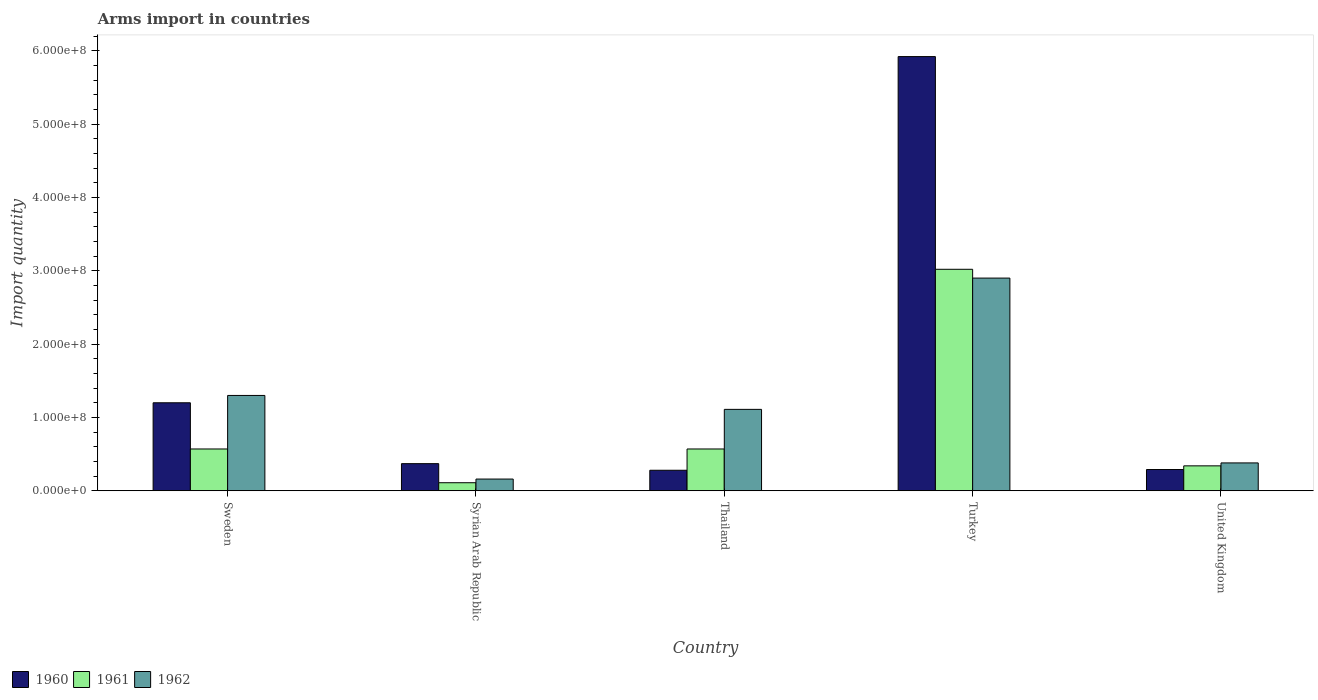How many different coloured bars are there?
Provide a succinct answer. 3. How many groups of bars are there?
Your answer should be compact. 5. Are the number of bars per tick equal to the number of legend labels?
Give a very brief answer. Yes. How many bars are there on the 4th tick from the left?
Provide a succinct answer. 3. How many bars are there on the 1st tick from the right?
Your answer should be compact. 3. What is the label of the 1st group of bars from the left?
Provide a succinct answer. Sweden. In how many cases, is the number of bars for a given country not equal to the number of legend labels?
Your answer should be compact. 0. What is the total arms import in 1960 in Sweden?
Your response must be concise. 1.20e+08. Across all countries, what is the maximum total arms import in 1961?
Your answer should be very brief. 3.02e+08. Across all countries, what is the minimum total arms import in 1962?
Make the answer very short. 1.60e+07. In which country was the total arms import in 1961 minimum?
Your response must be concise. Syrian Arab Republic. What is the total total arms import in 1960 in the graph?
Keep it short and to the point. 8.06e+08. What is the difference between the total arms import in 1962 in Thailand and that in United Kingdom?
Make the answer very short. 7.30e+07. What is the difference between the total arms import in 1960 in Sweden and the total arms import in 1962 in Turkey?
Offer a very short reply. -1.70e+08. What is the average total arms import in 1960 per country?
Offer a very short reply. 1.61e+08. What is the difference between the total arms import of/in 1960 and total arms import of/in 1961 in Syrian Arab Republic?
Your answer should be very brief. 2.60e+07. What is the ratio of the total arms import in 1961 in Sweden to that in Turkey?
Your answer should be compact. 0.19. Is the total arms import in 1961 in Syrian Arab Republic less than that in Turkey?
Make the answer very short. Yes. What is the difference between the highest and the second highest total arms import in 1961?
Offer a terse response. 2.45e+08. What is the difference between the highest and the lowest total arms import in 1962?
Make the answer very short. 2.74e+08. In how many countries, is the total arms import in 1960 greater than the average total arms import in 1960 taken over all countries?
Your answer should be very brief. 1. Is it the case that in every country, the sum of the total arms import in 1962 and total arms import in 1961 is greater than the total arms import in 1960?
Your response must be concise. No. How many bars are there?
Provide a short and direct response. 15. What is the difference between two consecutive major ticks on the Y-axis?
Provide a succinct answer. 1.00e+08. Are the values on the major ticks of Y-axis written in scientific E-notation?
Keep it short and to the point. Yes. How many legend labels are there?
Your answer should be very brief. 3. What is the title of the graph?
Give a very brief answer. Arms import in countries. What is the label or title of the Y-axis?
Give a very brief answer. Import quantity. What is the Import quantity of 1960 in Sweden?
Your answer should be compact. 1.20e+08. What is the Import quantity in 1961 in Sweden?
Provide a succinct answer. 5.70e+07. What is the Import quantity in 1962 in Sweden?
Ensure brevity in your answer.  1.30e+08. What is the Import quantity of 1960 in Syrian Arab Republic?
Your answer should be very brief. 3.70e+07. What is the Import quantity of 1961 in Syrian Arab Republic?
Your answer should be compact. 1.10e+07. What is the Import quantity in 1962 in Syrian Arab Republic?
Offer a very short reply. 1.60e+07. What is the Import quantity in 1960 in Thailand?
Give a very brief answer. 2.80e+07. What is the Import quantity in 1961 in Thailand?
Give a very brief answer. 5.70e+07. What is the Import quantity of 1962 in Thailand?
Your answer should be compact. 1.11e+08. What is the Import quantity in 1960 in Turkey?
Your answer should be very brief. 5.92e+08. What is the Import quantity in 1961 in Turkey?
Offer a terse response. 3.02e+08. What is the Import quantity in 1962 in Turkey?
Your answer should be compact. 2.90e+08. What is the Import quantity of 1960 in United Kingdom?
Your answer should be compact. 2.90e+07. What is the Import quantity in 1961 in United Kingdom?
Ensure brevity in your answer.  3.40e+07. What is the Import quantity of 1962 in United Kingdom?
Provide a short and direct response. 3.80e+07. Across all countries, what is the maximum Import quantity of 1960?
Provide a succinct answer. 5.92e+08. Across all countries, what is the maximum Import quantity in 1961?
Provide a short and direct response. 3.02e+08. Across all countries, what is the maximum Import quantity in 1962?
Your answer should be compact. 2.90e+08. Across all countries, what is the minimum Import quantity in 1960?
Offer a terse response. 2.80e+07. Across all countries, what is the minimum Import quantity in 1961?
Make the answer very short. 1.10e+07. Across all countries, what is the minimum Import quantity in 1962?
Provide a succinct answer. 1.60e+07. What is the total Import quantity of 1960 in the graph?
Provide a succinct answer. 8.06e+08. What is the total Import quantity of 1961 in the graph?
Your answer should be very brief. 4.61e+08. What is the total Import quantity of 1962 in the graph?
Give a very brief answer. 5.85e+08. What is the difference between the Import quantity of 1960 in Sweden and that in Syrian Arab Republic?
Provide a succinct answer. 8.30e+07. What is the difference between the Import quantity of 1961 in Sweden and that in Syrian Arab Republic?
Make the answer very short. 4.60e+07. What is the difference between the Import quantity in 1962 in Sweden and that in Syrian Arab Republic?
Keep it short and to the point. 1.14e+08. What is the difference between the Import quantity of 1960 in Sweden and that in Thailand?
Offer a very short reply. 9.20e+07. What is the difference between the Import quantity in 1962 in Sweden and that in Thailand?
Offer a terse response. 1.90e+07. What is the difference between the Import quantity of 1960 in Sweden and that in Turkey?
Give a very brief answer. -4.72e+08. What is the difference between the Import quantity of 1961 in Sweden and that in Turkey?
Make the answer very short. -2.45e+08. What is the difference between the Import quantity in 1962 in Sweden and that in Turkey?
Keep it short and to the point. -1.60e+08. What is the difference between the Import quantity of 1960 in Sweden and that in United Kingdom?
Provide a short and direct response. 9.10e+07. What is the difference between the Import quantity in 1961 in Sweden and that in United Kingdom?
Ensure brevity in your answer.  2.30e+07. What is the difference between the Import quantity of 1962 in Sweden and that in United Kingdom?
Make the answer very short. 9.20e+07. What is the difference between the Import quantity in 1960 in Syrian Arab Republic and that in Thailand?
Offer a terse response. 9.00e+06. What is the difference between the Import quantity in 1961 in Syrian Arab Republic and that in Thailand?
Offer a terse response. -4.60e+07. What is the difference between the Import quantity in 1962 in Syrian Arab Republic and that in Thailand?
Keep it short and to the point. -9.50e+07. What is the difference between the Import quantity of 1960 in Syrian Arab Republic and that in Turkey?
Provide a succinct answer. -5.55e+08. What is the difference between the Import quantity of 1961 in Syrian Arab Republic and that in Turkey?
Your answer should be compact. -2.91e+08. What is the difference between the Import quantity in 1962 in Syrian Arab Republic and that in Turkey?
Offer a very short reply. -2.74e+08. What is the difference between the Import quantity in 1961 in Syrian Arab Republic and that in United Kingdom?
Offer a very short reply. -2.30e+07. What is the difference between the Import quantity of 1962 in Syrian Arab Republic and that in United Kingdom?
Your response must be concise. -2.20e+07. What is the difference between the Import quantity in 1960 in Thailand and that in Turkey?
Your response must be concise. -5.64e+08. What is the difference between the Import quantity in 1961 in Thailand and that in Turkey?
Ensure brevity in your answer.  -2.45e+08. What is the difference between the Import quantity of 1962 in Thailand and that in Turkey?
Your answer should be very brief. -1.79e+08. What is the difference between the Import quantity in 1960 in Thailand and that in United Kingdom?
Your answer should be very brief. -1.00e+06. What is the difference between the Import quantity in 1961 in Thailand and that in United Kingdom?
Make the answer very short. 2.30e+07. What is the difference between the Import quantity in 1962 in Thailand and that in United Kingdom?
Offer a terse response. 7.30e+07. What is the difference between the Import quantity of 1960 in Turkey and that in United Kingdom?
Your answer should be compact. 5.63e+08. What is the difference between the Import quantity of 1961 in Turkey and that in United Kingdom?
Your answer should be very brief. 2.68e+08. What is the difference between the Import quantity of 1962 in Turkey and that in United Kingdom?
Give a very brief answer. 2.52e+08. What is the difference between the Import quantity in 1960 in Sweden and the Import quantity in 1961 in Syrian Arab Republic?
Provide a short and direct response. 1.09e+08. What is the difference between the Import quantity in 1960 in Sweden and the Import quantity in 1962 in Syrian Arab Republic?
Ensure brevity in your answer.  1.04e+08. What is the difference between the Import quantity in 1961 in Sweden and the Import quantity in 1962 in Syrian Arab Republic?
Your response must be concise. 4.10e+07. What is the difference between the Import quantity in 1960 in Sweden and the Import quantity in 1961 in Thailand?
Keep it short and to the point. 6.30e+07. What is the difference between the Import quantity in 1960 in Sweden and the Import quantity in 1962 in Thailand?
Your answer should be very brief. 9.00e+06. What is the difference between the Import quantity of 1961 in Sweden and the Import quantity of 1962 in Thailand?
Offer a terse response. -5.40e+07. What is the difference between the Import quantity in 1960 in Sweden and the Import quantity in 1961 in Turkey?
Your answer should be very brief. -1.82e+08. What is the difference between the Import quantity of 1960 in Sweden and the Import quantity of 1962 in Turkey?
Provide a succinct answer. -1.70e+08. What is the difference between the Import quantity in 1961 in Sweden and the Import quantity in 1962 in Turkey?
Keep it short and to the point. -2.33e+08. What is the difference between the Import quantity of 1960 in Sweden and the Import quantity of 1961 in United Kingdom?
Provide a short and direct response. 8.60e+07. What is the difference between the Import quantity in 1960 in Sweden and the Import quantity in 1962 in United Kingdom?
Keep it short and to the point. 8.20e+07. What is the difference between the Import quantity in 1961 in Sweden and the Import quantity in 1962 in United Kingdom?
Your answer should be compact. 1.90e+07. What is the difference between the Import quantity of 1960 in Syrian Arab Republic and the Import quantity of 1961 in Thailand?
Your answer should be very brief. -2.00e+07. What is the difference between the Import quantity in 1960 in Syrian Arab Republic and the Import quantity in 1962 in Thailand?
Keep it short and to the point. -7.40e+07. What is the difference between the Import quantity in 1961 in Syrian Arab Republic and the Import quantity in 1962 in Thailand?
Provide a succinct answer. -1.00e+08. What is the difference between the Import quantity of 1960 in Syrian Arab Republic and the Import quantity of 1961 in Turkey?
Give a very brief answer. -2.65e+08. What is the difference between the Import quantity of 1960 in Syrian Arab Republic and the Import quantity of 1962 in Turkey?
Your answer should be compact. -2.53e+08. What is the difference between the Import quantity in 1961 in Syrian Arab Republic and the Import quantity in 1962 in Turkey?
Offer a very short reply. -2.79e+08. What is the difference between the Import quantity in 1961 in Syrian Arab Republic and the Import quantity in 1962 in United Kingdom?
Make the answer very short. -2.70e+07. What is the difference between the Import quantity of 1960 in Thailand and the Import quantity of 1961 in Turkey?
Make the answer very short. -2.74e+08. What is the difference between the Import quantity of 1960 in Thailand and the Import quantity of 1962 in Turkey?
Provide a succinct answer. -2.62e+08. What is the difference between the Import quantity in 1961 in Thailand and the Import quantity in 1962 in Turkey?
Make the answer very short. -2.33e+08. What is the difference between the Import quantity of 1960 in Thailand and the Import quantity of 1961 in United Kingdom?
Your answer should be very brief. -6.00e+06. What is the difference between the Import quantity in 1960 in Thailand and the Import quantity in 1962 in United Kingdom?
Provide a succinct answer. -1.00e+07. What is the difference between the Import quantity of 1961 in Thailand and the Import quantity of 1962 in United Kingdom?
Your answer should be very brief. 1.90e+07. What is the difference between the Import quantity of 1960 in Turkey and the Import quantity of 1961 in United Kingdom?
Ensure brevity in your answer.  5.58e+08. What is the difference between the Import quantity of 1960 in Turkey and the Import quantity of 1962 in United Kingdom?
Offer a very short reply. 5.54e+08. What is the difference between the Import quantity of 1961 in Turkey and the Import quantity of 1962 in United Kingdom?
Your answer should be compact. 2.64e+08. What is the average Import quantity in 1960 per country?
Keep it short and to the point. 1.61e+08. What is the average Import quantity in 1961 per country?
Keep it short and to the point. 9.22e+07. What is the average Import quantity in 1962 per country?
Your response must be concise. 1.17e+08. What is the difference between the Import quantity of 1960 and Import quantity of 1961 in Sweden?
Make the answer very short. 6.30e+07. What is the difference between the Import quantity in 1960 and Import quantity in 1962 in Sweden?
Offer a very short reply. -1.00e+07. What is the difference between the Import quantity in 1961 and Import quantity in 1962 in Sweden?
Your answer should be compact. -7.30e+07. What is the difference between the Import quantity in 1960 and Import quantity in 1961 in Syrian Arab Republic?
Offer a very short reply. 2.60e+07. What is the difference between the Import quantity in 1960 and Import quantity in 1962 in Syrian Arab Republic?
Offer a terse response. 2.10e+07. What is the difference between the Import quantity in 1961 and Import quantity in 1962 in Syrian Arab Republic?
Offer a terse response. -5.00e+06. What is the difference between the Import quantity in 1960 and Import quantity in 1961 in Thailand?
Provide a succinct answer. -2.90e+07. What is the difference between the Import quantity in 1960 and Import quantity in 1962 in Thailand?
Make the answer very short. -8.30e+07. What is the difference between the Import quantity in 1961 and Import quantity in 1962 in Thailand?
Make the answer very short. -5.40e+07. What is the difference between the Import quantity in 1960 and Import quantity in 1961 in Turkey?
Your response must be concise. 2.90e+08. What is the difference between the Import quantity of 1960 and Import quantity of 1962 in Turkey?
Your answer should be very brief. 3.02e+08. What is the difference between the Import quantity in 1961 and Import quantity in 1962 in Turkey?
Offer a terse response. 1.20e+07. What is the difference between the Import quantity of 1960 and Import quantity of 1961 in United Kingdom?
Provide a succinct answer. -5.00e+06. What is the difference between the Import quantity in 1960 and Import quantity in 1962 in United Kingdom?
Give a very brief answer. -9.00e+06. What is the ratio of the Import quantity of 1960 in Sweden to that in Syrian Arab Republic?
Ensure brevity in your answer.  3.24. What is the ratio of the Import quantity of 1961 in Sweden to that in Syrian Arab Republic?
Give a very brief answer. 5.18. What is the ratio of the Import quantity in 1962 in Sweden to that in Syrian Arab Republic?
Provide a succinct answer. 8.12. What is the ratio of the Import quantity of 1960 in Sweden to that in Thailand?
Keep it short and to the point. 4.29. What is the ratio of the Import quantity in 1961 in Sweden to that in Thailand?
Provide a short and direct response. 1. What is the ratio of the Import quantity in 1962 in Sweden to that in Thailand?
Your response must be concise. 1.17. What is the ratio of the Import quantity of 1960 in Sweden to that in Turkey?
Provide a succinct answer. 0.2. What is the ratio of the Import quantity in 1961 in Sweden to that in Turkey?
Make the answer very short. 0.19. What is the ratio of the Import quantity in 1962 in Sweden to that in Turkey?
Provide a succinct answer. 0.45. What is the ratio of the Import quantity of 1960 in Sweden to that in United Kingdom?
Your response must be concise. 4.14. What is the ratio of the Import quantity of 1961 in Sweden to that in United Kingdom?
Keep it short and to the point. 1.68. What is the ratio of the Import quantity in 1962 in Sweden to that in United Kingdom?
Provide a succinct answer. 3.42. What is the ratio of the Import quantity of 1960 in Syrian Arab Republic to that in Thailand?
Ensure brevity in your answer.  1.32. What is the ratio of the Import quantity in 1961 in Syrian Arab Republic to that in Thailand?
Offer a terse response. 0.19. What is the ratio of the Import quantity of 1962 in Syrian Arab Republic to that in Thailand?
Ensure brevity in your answer.  0.14. What is the ratio of the Import quantity of 1960 in Syrian Arab Republic to that in Turkey?
Offer a very short reply. 0.06. What is the ratio of the Import quantity of 1961 in Syrian Arab Republic to that in Turkey?
Ensure brevity in your answer.  0.04. What is the ratio of the Import quantity of 1962 in Syrian Arab Republic to that in Turkey?
Your response must be concise. 0.06. What is the ratio of the Import quantity of 1960 in Syrian Arab Republic to that in United Kingdom?
Make the answer very short. 1.28. What is the ratio of the Import quantity in 1961 in Syrian Arab Republic to that in United Kingdom?
Keep it short and to the point. 0.32. What is the ratio of the Import quantity in 1962 in Syrian Arab Republic to that in United Kingdom?
Make the answer very short. 0.42. What is the ratio of the Import quantity in 1960 in Thailand to that in Turkey?
Your response must be concise. 0.05. What is the ratio of the Import quantity of 1961 in Thailand to that in Turkey?
Provide a succinct answer. 0.19. What is the ratio of the Import quantity in 1962 in Thailand to that in Turkey?
Provide a succinct answer. 0.38. What is the ratio of the Import quantity of 1960 in Thailand to that in United Kingdom?
Your answer should be very brief. 0.97. What is the ratio of the Import quantity of 1961 in Thailand to that in United Kingdom?
Offer a very short reply. 1.68. What is the ratio of the Import quantity in 1962 in Thailand to that in United Kingdom?
Keep it short and to the point. 2.92. What is the ratio of the Import quantity in 1960 in Turkey to that in United Kingdom?
Ensure brevity in your answer.  20.41. What is the ratio of the Import quantity of 1961 in Turkey to that in United Kingdom?
Offer a terse response. 8.88. What is the ratio of the Import quantity of 1962 in Turkey to that in United Kingdom?
Your response must be concise. 7.63. What is the difference between the highest and the second highest Import quantity in 1960?
Ensure brevity in your answer.  4.72e+08. What is the difference between the highest and the second highest Import quantity in 1961?
Ensure brevity in your answer.  2.45e+08. What is the difference between the highest and the second highest Import quantity of 1962?
Your response must be concise. 1.60e+08. What is the difference between the highest and the lowest Import quantity in 1960?
Your answer should be very brief. 5.64e+08. What is the difference between the highest and the lowest Import quantity of 1961?
Your answer should be very brief. 2.91e+08. What is the difference between the highest and the lowest Import quantity in 1962?
Your answer should be very brief. 2.74e+08. 